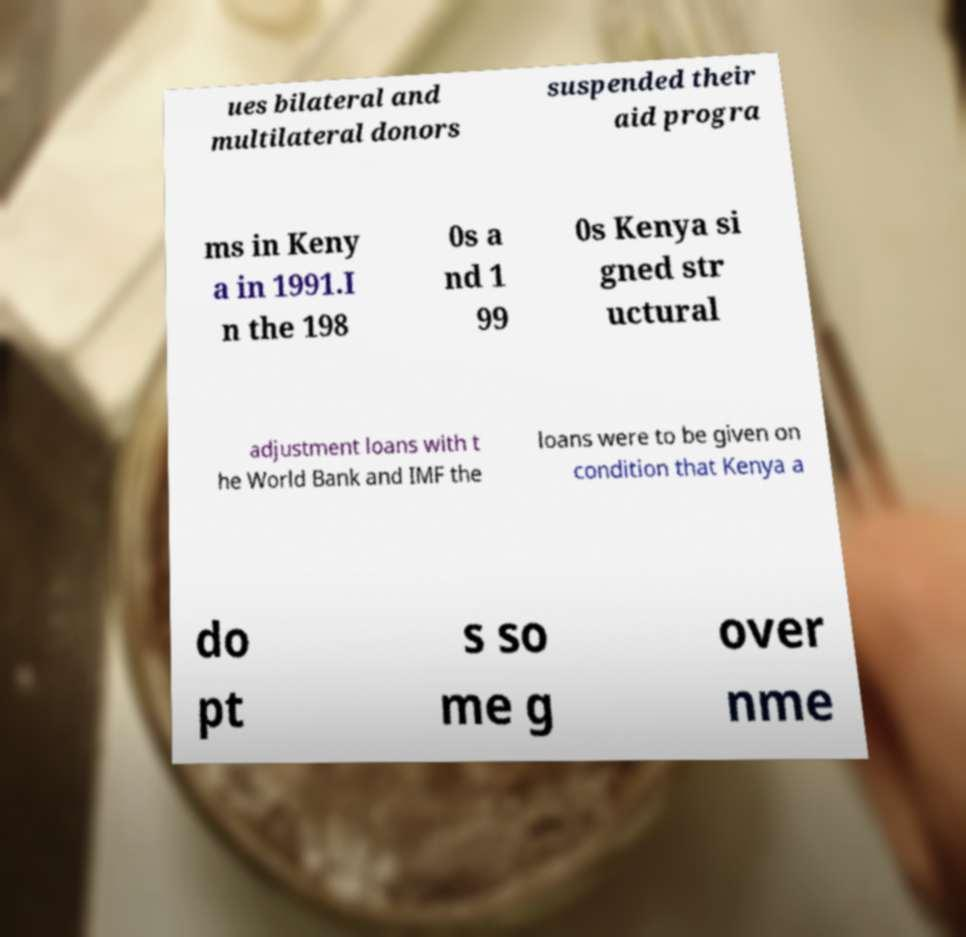Could you extract and type out the text from this image? ues bilateral and multilateral donors suspended their aid progra ms in Keny a in 1991.I n the 198 0s a nd 1 99 0s Kenya si gned str uctural adjustment loans with t he World Bank and IMF the loans were to be given on condition that Kenya a do pt s so me g over nme 